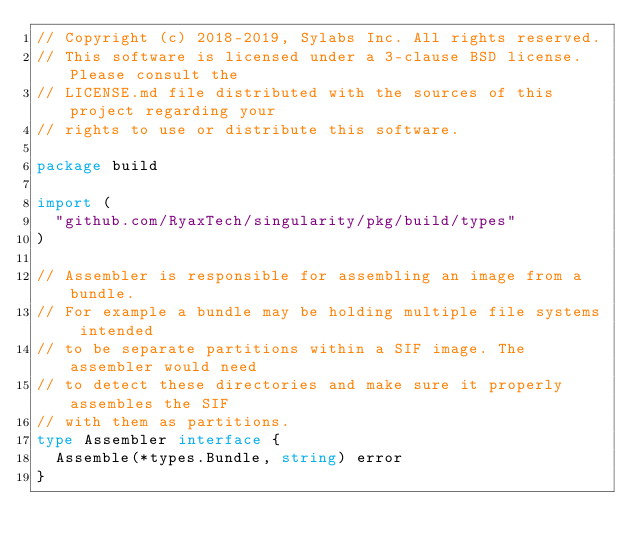Convert code to text. <code><loc_0><loc_0><loc_500><loc_500><_Go_>// Copyright (c) 2018-2019, Sylabs Inc. All rights reserved.
// This software is licensed under a 3-clause BSD license. Please consult the
// LICENSE.md file distributed with the sources of this project regarding your
// rights to use or distribute this software.

package build

import (
	"github.com/RyaxTech/singularity/pkg/build/types"
)

// Assembler is responsible for assembling an image from a bundle.
// For example a bundle may be holding multiple file systems intended
// to be separate partitions within a SIF image. The assembler would need
// to detect these directories and make sure it properly assembles the SIF
// with them as partitions.
type Assembler interface {
	Assemble(*types.Bundle, string) error
}
</code> 